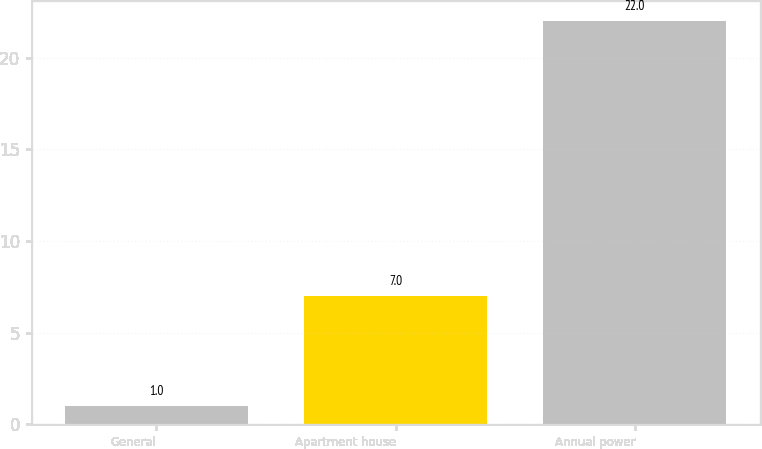<chart> <loc_0><loc_0><loc_500><loc_500><bar_chart><fcel>General<fcel>Apartment house<fcel>Annual power<nl><fcel>1<fcel>7<fcel>22<nl></chart> 